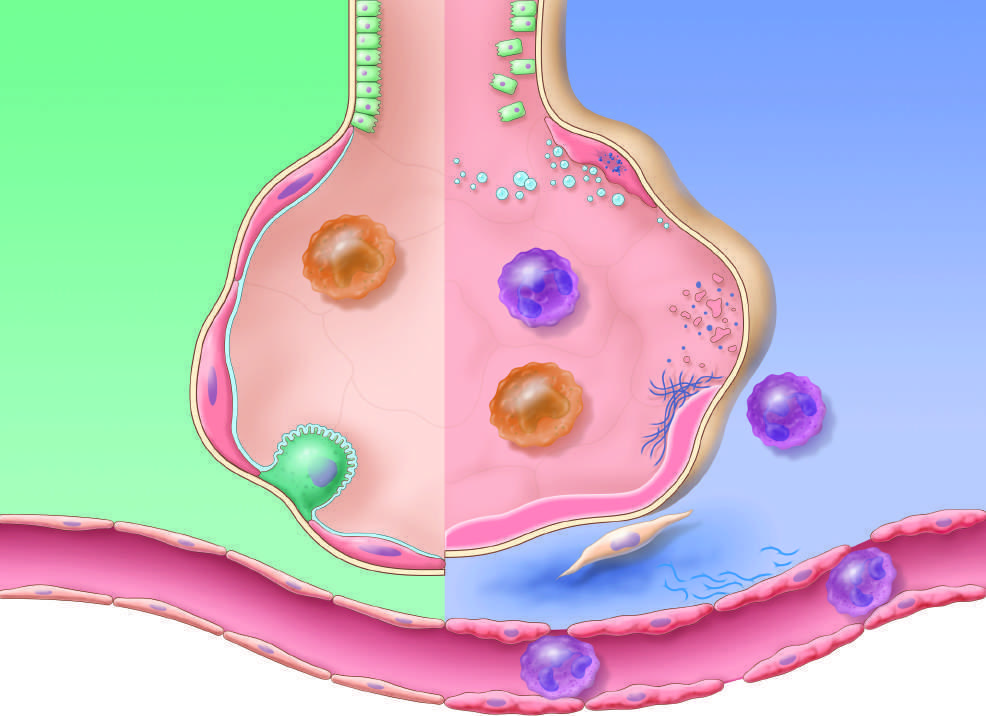do the release of macrophage-derived fibrogenic cytokines such as transforming growth factor-beta stimulate fibroblast growth and collagen deposition associated with the healing phase of injury?
Answer the question using a single word or phrase. Yes 